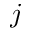<formula> <loc_0><loc_0><loc_500><loc_500>j</formula> 